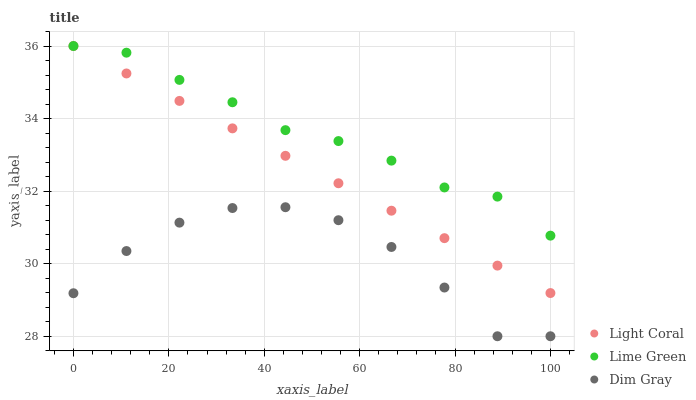Does Dim Gray have the minimum area under the curve?
Answer yes or no. Yes. Does Lime Green have the maximum area under the curve?
Answer yes or no. Yes. Does Lime Green have the minimum area under the curve?
Answer yes or no. No. Does Dim Gray have the maximum area under the curve?
Answer yes or no. No. Is Light Coral the smoothest?
Answer yes or no. Yes. Is Dim Gray the roughest?
Answer yes or no. Yes. Is Lime Green the smoothest?
Answer yes or no. No. Is Lime Green the roughest?
Answer yes or no. No. Does Dim Gray have the lowest value?
Answer yes or no. Yes. Does Lime Green have the lowest value?
Answer yes or no. No. Does Lime Green have the highest value?
Answer yes or no. Yes. Does Dim Gray have the highest value?
Answer yes or no. No. Is Dim Gray less than Lime Green?
Answer yes or no. Yes. Is Lime Green greater than Dim Gray?
Answer yes or no. Yes. Does Lime Green intersect Light Coral?
Answer yes or no. Yes. Is Lime Green less than Light Coral?
Answer yes or no. No. Is Lime Green greater than Light Coral?
Answer yes or no. No. Does Dim Gray intersect Lime Green?
Answer yes or no. No. 